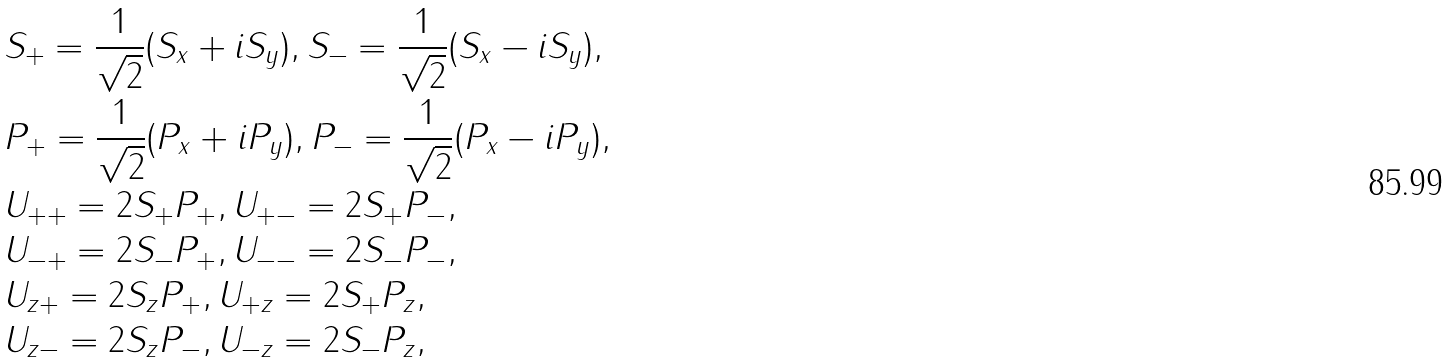<formula> <loc_0><loc_0><loc_500><loc_500>& S _ { + } = \frac { 1 } { \sqrt { 2 } } ( S _ { x } + i S _ { y } ) , S _ { - } = \frac { 1 } { \sqrt { 2 } } ( S _ { x } - i S _ { y } ) , \\ & P _ { + } = \frac { 1 } { \sqrt { 2 } } ( P _ { x } + i P _ { y } ) , P _ { - } = \frac { 1 } { \sqrt { 2 } } ( P _ { x } - i P _ { y } ) , \\ & U _ { + + } = 2 S _ { + } P _ { + } , U _ { + - } = 2 S _ { + } P _ { - } , \\ & U _ { - + } = 2 S _ { - } P _ { + } , U _ { - - } = 2 S _ { - } P _ { - } , \\ & U _ { z + } = 2 S _ { z } P _ { + } , U _ { + z } = 2 S _ { + } P _ { z } , \\ & U _ { z - } = 2 S _ { z } P _ { - } , U _ { - z } = 2 S _ { - } P _ { z } , \\</formula> 